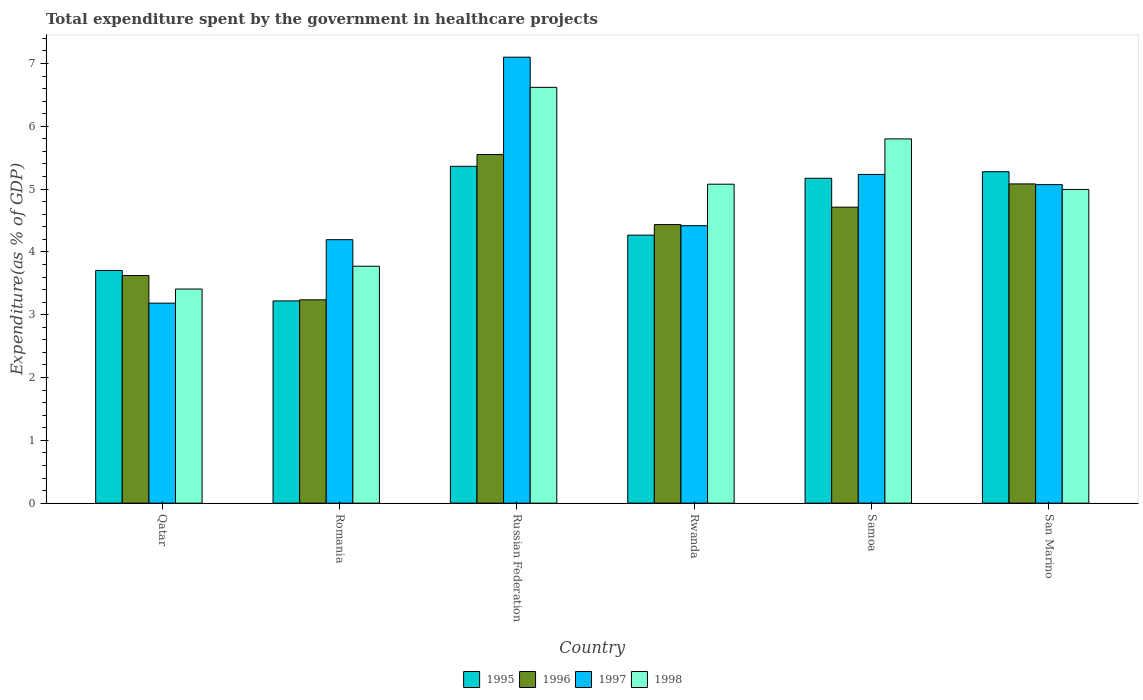Are the number of bars per tick equal to the number of legend labels?
Ensure brevity in your answer.  Yes. Are the number of bars on each tick of the X-axis equal?
Offer a terse response. Yes. How many bars are there on the 4th tick from the left?
Keep it short and to the point. 4. What is the label of the 6th group of bars from the left?
Your answer should be compact. San Marino. In how many cases, is the number of bars for a given country not equal to the number of legend labels?
Give a very brief answer. 0. What is the total expenditure spent by the government in healthcare projects in 1995 in Russian Federation?
Give a very brief answer. 5.36. Across all countries, what is the maximum total expenditure spent by the government in healthcare projects in 1997?
Make the answer very short. 7.1. Across all countries, what is the minimum total expenditure spent by the government in healthcare projects in 1996?
Your answer should be compact. 3.24. In which country was the total expenditure spent by the government in healthcare projects in 1997 maximum?
Offer a very short reply. Russian Federation. In which country was the total expenditure spent by the government in healthcare projects in 1995 minimum?
Keep it short and to the point. Romania. What is the total total expenditure spent by the government in healthcare projects in 1996 in the graph?
Provide a short and direct response. 26.64. What is the difference between the total expenditure spent by the government in healthcare projects in 1995 in Russian Federation and that in Rwanda?
Your response must be concise. 1.1. What is the difference between the total expenditure spent by the government in healthcare projects in 1996 in Rwanda and the total expenditure spent by the government in healthcare projects in 1997 in Romania?
Your answer should be very brief. 0.24. What is the average total expenditure spent by the government in healthcare projects in 1996 per country?
Provide a short and direct response. 4.44. What is the difference between the total expenditure spent by the government in healthcare projects of/in 1997 and total expenditure spent by the government in healthcare projects of/in 1998 in Rwanda?
Offer a terse response. -0.66. In how many countries, is the total expenditure spent by the government in healthcare projects in 1997 greater than 7.2 %?
Make the answer very short. 0. What is the ratio of the total expenditure spent by the government in healthcare projects in 1996 in Romania to that in Samoa?
Your answer should be compact. 0.69. Is the total expenditure spent by the government in healthcare projects in 1997 in Qatar less than that in San Marino?
Provide a succinct answer. Yes. Is the difference between the total expenditure spent by the government in healthcare projects in 1997 in Romania and Russian Federation greater than the difference between the total expenditure spent by the government in healthcare projects in 1998 in Romania and Russian Federation?
Your response must be concise. No. What is the difference between the highest and the second highest total expenditure spent by the government in healthcare projects in 1995?
Offer a very short reply. -0.1. What is the difference between the highest and the lowest total expenditure spent by the government in healthcare projects in 1996?
Give a very brief answer. 2.31. In how many countries, is the total expenditure spent by the government in healthcare projects in 1997 greater than the average total expenditure spent by the government in healthcare projects in 1997 taken over all countries?
Provide a short and direct response. 3. Is the sum of the total expenditure spent by the government in healthcare projects in 1995 in Russian Federation and Samoa greater than the maximum total expenditure spent by the government in healthcare projects in 1997 across all countries?
Offer a very short reply. Yes. Is it the case that in every country, the sum of the total expenditure spent by the government in healthcare projects in 1995 and total expenditure spent by the government in healthcare projects in 1998 is greater than the sum of total expenditure spent by the government in healthcare projects in 1997 and total expenditure spent by the government in healthcare projects in 1996?
Your answer should be very brief. No. How many bars are there?
Provide a succinct answer. 24. How many countries are there in the graph?
Your answer should be very brief. 6. What is the difference between two consecutive major ticks on the Y-axis?
Provide a succinct answer. 1. Does the graph contain any zero values?
Keep it short and to the point. No. Does the graph contain grids?
Make the answer very short. No. How many legend labels are there?
Your answer should be compact. 4. How are the legend labels stacked?
Your answer should be very brief. Horizontal. What is the title of the graph?
Offer a very short reply. Total expenditure spent by the government in healthcare projects. What is the label or title of the Y-axis?
Your response must be concise. Expenditure(as % of GDP). What is the Expenditure(as % of GDP) in 1995 in Qatar?
Offer a very short reply. 3.7. What is the Expenditure(as % of GDP) of 1996 in Qatar?
Offer a very short reply. 3.62. What is the Expenditure(as % of GDP) of 1997 in Qatar?
Provide a succinct answer. 3.18. What is the Expenditure(as % of GDP) in 1998 in Qatar?
Your response must be concise. 3.41. What is the Expenditure(as % of GDP) of 1995 in Romania?
Keep it short and to the point. 3.22. What is the Expenditure(as % of GDP) of 1996 in Romania?
Provide a succinct answer. 3.24. What is the Expenditure(as % of GDP) of 1997 in Romania?
Your response must be concise. 4.19. What is the Expenditure(as % of GDP) of 1998 in Romania?
Ensure brevity in your answer.  3.77. What is the Expenditure(as % of GDP) in 1995 in Russian Federation?
Your answer should be very brief. 5.36. What is the Expenditure(as % of GDP) in 1996 in Russian Federation?
Offer a terse response. 5.55. What is the Expenditure(as % of GDP) in 1997 in Russian Federation?
Your response must be concise. 7.1. What is the Expenditure(as % of GDP) of 1998 in Russian Federation?
Ensure brevity in your answer.  6.62. What is the Expenditure(as % of GDP) in 1995 in Rwanda?
Give a very brief answer. 4.27. What is the Expenditure(as % of GDP) of 1996 in Rwanda?
Your answer should be compact. 4.44. What is the Expenditure(as % of GDP) of 1997 in Rwanda?
Your answer should be compact. 4.42. What is the Expenditure(as % of GDP) in 1998 in Rwanda?
Provide a succinct answer. 5.08. What is the Expenditure(as % of GDP) of 1995 in Samoa?
Make the answer very short. 5.17. What is the Expenditure(as % of GDP) of 1996 in Samoa?
Your answer should be compact. 4.71. What is the Expenditure(as % of GDP) in 1997 in Samoa?
Your response must be concise. 5.23. What is the Expenditure(as % of GDP) of 1998 in Samoa?
Keep it short and to the point. 5.8. What is the Expenditure(as % of GDP) in 1995 in San Marino?
Offer a very short reply. 5.28. What is the Expenditure(as % of GDP) of 1996 in San Marino?
Offer a very short reply. 5.08. What is the Expenditure(as % of GDP) of 1997 in San Marino?
Keep it short and to the point. 5.07. What is the Expenditure(as % of GDP) of 1998 in San Marino?
Keep it short and to the point. 4.99. Across all countries, what is the maximum Expenditure(as % of GDP) of 1995?
Offer a very short reply. 5.36. Across all countries, what is the maximum Expenditure(as % of GDP) in 1996?
Your answer should be very brief. 5.55. Across all countries, what is the maximum Expenditure(as % of GDP) of 1997?
Provide a short and direct response. 7.1. Across all countries, what is the maximum Expenditure(as % of GDP) of 1998?
Make the answer very short. 6.62. Across all countries, what is the minimum Expenditure(as % of GDP) in 1995?
Keep it short and to the point. 3.22. Across all countries, what is the minimum Expenditure(as % of GDP) in 1996?
Your response must be concise. 3.24. Across all countries, what is the minimum Expenditure(as % of GDP) in 1997?
Offer a very short reply. 3.18. Across all countries, what is the minimum Expenditure(as % of GDP) of 1998?
Your answer should be very brief. 3.41. What is the total Expenditure(as % of GDP) in 1995 in the graph?
Provide a short and direct response. 27. What is the total Expenditure(as % of GDP) in 1996 in the graph?
Keep it short and to the point. 26.64. What is the total Expenditure(as % of GDP) of 1997 in the graph?
Give a very brief answer. 29.2. What is the total Expenditure(as % of GDP) in 1998 in the graph?
Keep it short and to the point. 29.67. What is the difference between the Expenditure(as % of GDP) of 1995 in Qatar and that in Romania?
Give a very brief answer. 0.48. What is the difference between the Expenditure(as % of GDP) of 1996 in Qatar and that in Romania?
Give a very brief answer. 0.39. What is the difference between the Expenditure(as % of GDP) in 1997 in Qatar and that in Romania?
Your answer should be compact. -1.01. What is the difference between the Expenditure(as % of GDP) of 1998 in Qatar and that in Romania?
Provide a succinct answer. -0.36. What is the difference between the Expenditure(as % of GDP) of 1995 in Qatar and that in Russian Federation?
Make the answer very short. -1.66. What is the difference between the Expenditure(as % of GDP) in 1996 in Qatar and that in Russian Federation?
Ensure brevity in your answer.  -1.93. What is the difference between the Expenditure(as % of GDP) in 1997 in Qatar and that in Russian Federation?
Provide a succinct answer. -3.92. What is the difference between the Expenditure(as % of GDP) of 1998 in Qatar and that in Russian Federation?
Ensure brevity in your answer.  -3.21. What is the difference between the Expenditure(as % of GDP) in 1995 in Qatar and that in Rwanda?
Give a very brief answer. -0.56. What is the difference between the Expenditure(as % of GDP) in 1996 in Qatar and that in Rwanda?
Your response must be concise. -0.81. What is the difference between the Expenditure(as % of GDP) in 1997 in Qatar and that in Rwanda?
Give a very brief answer. -1.23. What is the difference between the Expenditure(as % of GDP) in 1998 in Qatar and that in Rwanda?
Offer a terse response. -1.67. What is the difference between the Expenditure(as % of GDP) in 1995 in Qatar and that in Samoa?
Keep it short and to the point. -1.47. What is the difference between the Expenditure(as % of GDP) in 1996 in Qatar and that in Samoa?
Make the answer very short. -1.09. What is the difference between the Expenditure(as % of GDP) in 1997 in Qatar and that in Samoa?
Provide a short and direct response. -2.05. What is the difference between the Expenditure(as % of GDP) in 1998 in Qatar and that in Samoa?
Offer a very short reply. -2.39. What is the difference between the Expenditure(as % of GDP) of 1995 in Qatar and that in San Marino?
Provide a succinct answer. -1.57. What is the difference between the Expenditure(as % of GDP) of 1996 in Qatar and that in San Marino?
Ensure brevity in your answer.  -1.46. What is the difference between the Expenditure(as % of GDP) of 1997 in Qatar and that in San Marino?
Make the answer very short. -1.89. What is the difference between the Expenditure(as % of GDP) in 1998 in Qatar and that in San Marino?
Provide a succinct answer. -1.59. What is the difference between the Expenditure(as % of GDP) of 1995 in Romania and that in Russian Federation?
Ensure brevity in your answer.  -2.14. What is the difference between the Expenditure(as % of GDP) of 1996 in Romania and that in Russian Federation?
Make the answer very short. -2.31. What is the difference between the Expenditure(as % of GDP) in 1997 in Romania and that in Russian Federation?
Make the answer very short. -2.91. What is the difference between the Expenditure(as % of GDP) of 1998 in Romania and that in Russian Federation?
Your response must be concise. -2.85. What is the difference between the Expenditure(as % of GDP) in 1995 in Romania and that in Rwanda?
Make the answer very short. -1.05. What is the difference between the Expenditure(as % of GDP) of 1996 in Romania and that in Rwanda?
Provide a succinct answer. -1.2. What is the difference between the Expenditure(as % of GDP) of 1997 in Romania and that in Rwanda?
Provide a short and direct response. -0.22. What is the difference between the Expenditure(as % of GDP) of 1998 in Romania and that in Rwanda?
Provide a short and direct response. -1.31. What is the difference between the Expenditure(as % of GDP) of 1995 in Romania and that in Samoa?
Make the answer very short. -1.95. What is the difference between the Expenditure(as % of GDP) in 1996 in Romania and that in Samoa?
Offer a terse response. -1.48. What is the difference between the Expenditure(as % of GDP) in 1997 in Romania and that in Samoa?
Ensure brevity in your answer.  -1.04. What is the difference between the Expenditure(as % of GDP) of 1998 in Romania and that in Samoa?
Provide a short and direct response. -2.03. What is the difference between the Expenditure(as % of GDP) in 1995 in Romania and that in San Marino?
Your answer should be compact. -2.06. What is the difference between the Expenditure(as % of GDP) of 1996 in Romania and that in San Marino?
Keep it short and to the point. -1.85. What is the difference between the Expenditure(as % of GDP) in 1997 in Romania and that in San Marino?
Make the answer very short. -0.88. What is the difference between the Expenditure(as % of GDP) of 1998 in Romania and that in San Marino?
Your answer should be compact. -1.22. What is the difference between the Expenditure(as % of GDP) in 1995 in Russian Federation and that in Rwanda?
Offer a very short reply. 1.1. What is the difference between the Expenditure(as % of GDP) in 1996 in Russian Federation and that in Rwanda?
Offer a very short reply. 1.12. What is the difference between the Expenditure(as % of GDP) in 1997 in Russian Federation and that in Rwanda?
Provide a succinct answer. 2.68. What is the difference between the Expenditure(as % of GDP) of 1998 in Russian Federation and that in Rwanda?
Give a very brief answer. 1.54. What is the difference between the Expenditure(as % of GDP) in 1995 in Russian Federation and that in Samoa?
Make the answer very short. 0.19. What is the difference between the Expenditure(as % of GDP) of 1996 in Russian Federation and that in Samoa?
Your response must be concise. 0.84. What is the difference between the Expenditure(as % of GDP) of 1997 in Russian Federation and that in Samoa?
Provide a succinct answer. 1.87. What is the difference between the Expenditure(as % of GDP) in 1998 in Russian Federation and that in Samoa?
Your response must be concise. 0.82. What is the difference between the Expenditure(as % of GDP) of 1995 in Russian Federation and that in San Marino?
Give a very brief answer. 0.09. What is the difference between the Expenditure(as % of GDP) in 1996 in Russian Federation and that in San Marino?
Your answer should be very brief. 0.47. What is the difference between the Expenditure(as % of GDP) in 1997 in Russian Federation and that in San Marino?
Provide a succinct answer. 2.03. What is the difference between the Expenditure(as % of GDP) of 1998 in Russian Federation and that in San Marino?
Ensure brevity in your answer.  1.63. What is the difference between the Expenditure(as % of GDP) of 1995 in Rwanda and that in Samoa?
Give a very brief answer. -0.91. What is the difference between the Expenditure(as % of GDP) in 1996 in Rwanda and that in Samoa?
Offer a terse response. -0.28. What is the difference between the Expenditure(as % of GDP) in 1997 in Rwanda and that in Samoa?
Offer a very short reply. -0.82. What is the difference between the Expenditure(as % of GDP) of 1998 in Rwanda and that in Samoa?
Ensure brevity in your answer.  -0.72. What is the difference between the Expenditure(as % of GDP) of 1995 in Rwanda and that in San Marino?
Provide a succinct answer. -1.01. What is the difference between the Expenditure(as % of GDP) of 1996 in Rwanda and that in San Marino?
Offer a terse response. -0.65. What is the difference between the Expenditure(as % of GDP) in 1997 in Rwanda and that in San Marino?
Give a very brief answer. -0.65. What is the difference between the Expenditure(as % of GDP) of 1998 in Rwanda and that in San Marino?
Provide a succinct answer. 0.08. What is the difference between the Expenditure(as % of GDP) in 1995 in Samoa and that in San Marino?
Ensure brevity in your answer.  -0.1. What is the difference between the Expenditure(as % of GDP) of 1996 in Samoa and that in San Marino?
Keep it short and to the point. -0.37. What is the difference between the Expenditure(as % of GDP) of 1997 in Samoa and that in San Marino?
Ensure brevity in your answer.  0.16. What is the difference between the Expenditure(as % of GDP) of 1998 in Samoa and that in San Marino?
Provide a succinct answer. 0.8. What is the difference between the Expenditure(as % of GDP) of 1995 in Qatar and the Expenditure(as % of GDP) of 1996 in Romania?
Give a very brief answer. 0.47. What is the difference between the Expenditure(as % of GDP) in 1995 in Qatar and the Expenditure(as % of GDP) in 1997 in Romania?
Ensure brevity in your answer.  -0.49. What is the difference between the Expenditure(as % of GDP) of 1995 in Qatar and the Expenditure(as % of GDP) of 1998 in Romania?
Offer a terse response. -0.07. What is the difference between the Expenditure(as % of GDP) of 1996 in Qatar and the Expenditure(as % of GDP) of 1997 in Romania?
Your response must be concise. -0.57. What is the difference between the Expenditure(as % of GDP) in 1996 in Qatar and the Expenditure(as % of GDP) in 1998 in Romania?
Offer a very short reply. -0.15. What is the difference between the Expenditure(as % of GDP) of 1997 in Qatar and the Expenditure(as % of GDP) of 1998 in Romania?
Make the answer very short. -0.59. What is the difference between the Expenditure(as % of GDP) in 1995 in Qatar and the Expenditure(as % of GDP) in 1996 in Russian Federation?
Keep it short and to the point. -1.85. What is the difference between the Expenditure(as % of GDP) of 1995 in Qatar and the Expenditure(as % of GDP) of 1997 in Russian Federation?
Your response must be concise. -3.4. What is the difference between the Expenditure(as % of GDP) of 1995 in Qatar and the Expenditure(as % of GDP) of 1998 in Russian Federation?
Give a very brief answer. -2.92. What is the difference between the Expenditure(as % of GDP) in 1996 in Qatar and the Expenditure(as % of GDP) in 1997 in Russian Federation?
Offer a very short reply. -3.48. What is the difference between the Expenditure(as % of GDP) in 1996 in Qatar and the Expenditure(as % of GDP) in 1998 in Russian Federation?
Make the answer very short. -3. What is the difference between the Expenditure(as % of GDP) of 1997 in Qatar and the Expenditure(as % of GDP) of 1998 in Russian Federation?
Keep it short and to the point. -3.44. What is the difference between the Expenditure(as % of GDP) of 1995 in Qatar and the Expenditure(as % of GDP) of 1996 in Rwanda?
Provide a succinct answer. -0.73. What is the difference between the Expenditure(as % of GDP) of 1995 in Qatar and the Expenditure(as % of GDP) of 1997 in Rwanda?
Provide a succinct answer. -0.71. What is the difference between the Expenditure(as % of GDP) of 1995 in Qatar and the Expenditure(as % of GDP) of 1998 in Rwanda?
Give a very brief answer. -1.37. What is the difference between the Expenditure(as % of GDP) in 1996 in Qatar and the Expenditure(as % of GDP) in 1997 in Rwanda?
Keep it short and to the point. -0.79. What is the difference between the Expenditure(as % of GDP) in 1996 in Qatar and the Expenditure(as % of GDP) in 1998 in Rwanda?
Provide a short and direct response. -1.45. What is the difference between the Expenditure(as % of GDP) of 1997 in Qatar and the Expenditure(as % of GDP) of 1998 in Rwanda?
Offer a very short reply. -1.89. What is the difference between the Expenditure(as % of GDP) in 1995 in Qatar and the Expenditure(as % of GDP) in 1996 in Samoa?
Your answer should be compact. -1.01. What is the difference between the Expenditure(as % of GDP) in 1995 in Qatar and the Expenditure(as % of GDP) in 1997 in Samoa?
Your answer should be compact. -1.53. What is the difference between the Expenditure(as % of GDP) in 1995 in Qatar and the Expenditure(as % of GDP) in 1998 in Samoa?
Provide a succinct answer. -2.09. What is the difference between the Expenditure(as % of GDP) of 1996 in Qatar and the Expenditure(as % of GDP) of 1997 in Samoa?
Give a very brief answer. -1.61. What is the difference between the Expenditure(as % of GDP) in 1996 in Qatar and the Expenditure(as % of GDP) in 1998 in Samoa?
Provide a succinct answer. -2.18. What is the difference between the Expenditure(as % of GDP) of 1997 in Qatar and the Expenditure(as % of GDP) of 1998 in Samoa?
Your answer should be compact. -2.61. What is the difference between the Expenditure(as % of GDP) in 1995 in Qatar and the Expenditure(as % of GDP) in 1996 in San Marino?
Give a very brief answer. -1.38. What is the difference between the Expenditure(as % of GDP) of 1995 in Qatar and the Expenditure(as % of GDP) of 1997 in San Marino?
Your answer should be very brief. -1.37. What is the difference between the Expenditure(as % of GDP) in 1995 in Qatar and the Expenditure(as % of GDP) in 1998 in San Marino?
Keep it short and to the point. -1.29. What is the difference between the Expenditure(as % of GDP) of 1996 in Qatar and the Expenditure(as % of GDP) of 1997 in San Marino?
Give a very brief answer. -1.45. What is the difference between the Expenditure(as % of GDP) in 1996 in Qatar and the Expenditure(as % of GDP) in 1998 in San Marino?
Make the answer very short. -1.37. What is the difference between the Expenditure(as % of GDP) in 1997 in Qatar and the Expenditure(as % of GDP) in 1998 in San Marino?
Provide a short and direct response. -1.81. What is the difference between the Expenditure(as % of GDP) of 1995 in Romania and the Expenditure(as % of GDP) of 1996 in Russian Federation?
Your answer should be compact. -2.33. What is the difference between the Expenditure(as % of GDP) of 1995 in Romania and the Expenditure(as % of GDP) of 1997 in Russian Federation?
Provide a short and direct response. -3.88. What is the difference between the Expenditure(as % of GDP) of 1995 in Romania and the Expenditure(as % of GDP) of 1998 in Russian Federation?
Provide a short and direct response. -3.4. What is the difference between the Expenditure(as % of GDP) in 1996 in Romania and the Expenditure(as % of GDP) in 1997 in Russian Federation?
Make the answer very short. -3.86. What is the difference between the Expenditure(as % of GDP) of 1996 in Romania and the Expenditure(as % of GDP) of 1998 in Russian Federation?
Your answer should be compact. -3.38. What is the difference between the Expenditure(as % of GDP) of 1997 in Romania and the Expenditure(as % of GDP) of 1998 in Russian Federation?
Give a very brief answer. -2.43. What is the difference between the Expenditure(as % of GDP) of 1995 in Romania and the Expenditure(as % of GDP) of 1996 in Rwanda?
Provide a short and direct response. -1.22. What is the difference between the Expenditure(as % of GDP) in 1995 in Romania and the Expenditure(as % of GDP) in 1997 in Rwanda?
Provide a succinct answer. -1.2. What is the difference between the Expenditure(as % of GDP) in 1995 in Romania and the Expenditure(as % of GDP) in 1998 in Rwanda?
Your response must be concise. -1.86. What is the difference between the Expenditure(as % of GDP) in 1996 in Romania and the Expenditure(as % of GDP) in 1997 in Rwanda?
Provide a short and direct response. -1.18. What is the difference between the Expenditure(as % of GDP) of 1996 in Romania and the Expenditure(as % of GDP) of 1998 in Rwanda?
Make the answer very short. -1.84. What is the difference between the Expenditure(as % of GDP) in 1997 in Romania and the Expenditure(as % of GDP) in 1998 in Rwanda?
Your response must be concise. -0.88. What is the difference between the Expenditure(as % of GDP) in 1995 in Romania and the Expenditure(as % of GDP) in 1996 in Samoa?
Keep it short and to the point. -1.49. What is the difference between the Expenditure(as % of GDP) of 1995 in Romania and the Expenditure(as % of GDP) of 1997 in Samoa?
Provide a short and direct response. -2.01. What is the difference between the Expenditure(as % of GDP) of 1995 in Romania and the Expenditure(as % of GDP) of 1998 in Samoa?
Your answer should be compact. -2.58. What is the difference between the Expenditure(as % of GDP) of 1996 in Romania and the Expenditure(as % of GDP) of 1997 in Samoa?
Give a very brief answer. -2. What is the difference between the Expenditure(as % of GDP) of 1996 in Romania and the Expenditure(as % of GDP) of 1998 in Samoa?
Your answer should be very brief. -2.56. What is the difference between the Expenditure(as % of GDP) in 1997 in Romania and the Expenditure(as % of GDP) in 1998 in Samoa?
Offer a terse response. -1.6. What is the difference between the Expenditure(as % of GDP) of 1995 in Romania and the Expenditure(as % of GDP) of 1996 in San Marino?
Offer a terse response. -1.86. What is the difference between the Expenditure(as % of GDP) of 1995 in Romania and the Expenditure(as % of GDP) of 1997 in San Marino?
Make the answer very short. -1.85. What is the difference between the Expenditure(as % of GDP) of 1995 in Romania and the Expenditure(as % of GDP) of 1998 in San Marino?
Offer a terse response. -1.77. What is the difference between the Expenditure(as % of GDP) of 1996 in Romania and the Expenditure(as % of GDP) of 1997 in San Marino?
Offer a very short reply. -1.83. What is the difference between the Expenditure(as % of GDP) of 1996 in Romania and the Expenditure(as % of GDP) of 1998 in San Marino?
Your response must be concise. -1.76. What is the difference between the Expenditure(as % of GDP) of 1997 in Romania and the Expenditure(as % of GDP) of 1998 in San Marino?
Ensure brevity in your answer.  -0.8. What is the difference between the Expenditure(as % of GDP) of 1995 in Russian Federation and the Expenditure(as % of GDP) of 1996 in Rwanda?
Make the answer very short. 0.93. What is the difference between the Expenditure(as % of GDP) of 1995 in Russian Federation and the Expenditure(as % of GDP) of 1997 in Rwanda?
Your answer should be very brief. 0.95. What is the difference between the Expenditure(as % of GDP) in 1995 in Russian Federation and the Expenditure(as % of GDP) in 1998 in Rwanda?
Your answer should be compact. 0.28. What is the difference between the Expenditure(as % of GDP) of 1996 in Russian Federation and the Expenditure(as % of GDP) of 1997 in Rwanda?
Your answer should be very brief. 1.13. What is the difference between the Expenditure(as % of GDP) in 1996 in Russian Federation and the Expenditure(as % of GDP) in 1998 in Rwanda?
Make the answer very short. 0.47. What is the difference between the Expenditure(as % of GDP) of 1997 in Russian Federation and the Expenditure(as % of GDP) of 1998 in Rwanda?
Provide a short and direct response. 2.02. What is the difference between the Expenditure(as % of GDP) of 1995 in Russian Federation and the Expenditure(as % of GDP) of 1996 in Samoa?
Provide a succinct answer. 0.65. What is the difference between the Expenditure(as % of GDP) of 1995 in Russian Federation and the Expenditure(as % of GDP) of 1997 in Samoa?
Offer a terse response. 0.13. What is the difference between the Expenditure(as % of GDP) of 1995 in Russian Federation and the Expenditure(as % of GDP) of 1998 in Samoa?
Keep it short and to the point. -0.44. What is the difference between the Expenditure(as % of GDP) in 1996 in Russian Federation and the Expenditure(as % of GDP) in 1997 in Samoa?
Provide a short and direct response. 0.32. What is the difference between the Expenditure(as % of GDP) of 1996 in Russian Federation and the Expenditure(as % of GDP) of 1998 in Samoa?
Offer a terse response. -0.25. What is the difference between the Expenditure(as % of GDP) in 1997 in Russian Federation and the Expenditure(as % of GDP) in 1998 in Samoa?
Make the answer very short. 1.3. What is the difference between the Expenditure(as % of GDP) of 1995 in Russian Federation and the Expenditure(as % of GDP) of 1996 in San Marino?
Your answer should be very brief. 0.28. What is the difference between the Expenditure(as % of GDP) in 1995 in Russian Federation and the Expenditure(as % of GDP) in 1997 in San Marino?
Provide a short and direct response. 0.29. What is the difference between the Expenditure(as % of GDP) in 1995 in Russian Federation and the Expenditure(as % of GDP) in 1998 in San Marino?
Make the answer very short. 0.37. What is the difference between the Expenditure(as % of GDP) in 1996 in Russian Federation and the Expenditure(as % of GDP) in 1997 in San Marino?
Offer a very short reply. 0.48. What is the difference between the Expenditure(as % of GDP) in 1996 in Russian Federation and the Expenditure(as % of GDP) in 1998 in San Marino?
Offer a terse response. 0.56. What is the difference between the Expenditure(as % of GDP) in 1997 in Russian Federation and the Expenditure(as % of GDP) in 1998 in San Marino?
Your response must be concise. 2.11. What is the difference between the Expenditure(as % of GDP) of 1995 in Rwanda and the Expenditure(as % of GDP) of 1996 in Samoa?
Your response must be concise. -0.44. What is the difference between the Expenditure(as % of GDP) of 1995 in Rwanda and the Expenditure(as % of GDP) of 1997 in Samoa?
Give a very brief answer. -0.97. What is the difference between the Expenditure(as % of GDP) in 1995 in Rwanda and the Expenditure(as % of GDP) in 1998 in Samoa?
Keep it short and to the point. -1.53. What is the difference between the Expenditure(as % of GDP) of 1996 in Rwanda and the Expenditure(as % of GDP) of 1997 in Samoa?
Give a very brief answer. -0.8. What is the difference between the Expenditure(as % of GDP) in 1996 in Rwanda and the Expenditure(as % of GDP) in 1998 in Samoa?
Your answer should be compact. -1.36. What is the difference between the Expenditure(as % of GDP) of 1997 in Rwanda and the Expenditure(as % of GDP) of 1998 in Samoa?
Ensure brevity in your answer.  -1.38. What is the difference between the Expenditure(as % of GDP) in 1995 in Rwanda and the Expenditure(as % of GDP) in 1996 in San Marino?
Make the answer very short. -0.82. What is the difference between the Expenditure(as % of GDP) in 1995 in Rwanda and the Expenditure(as % of GDP) in 1997 in San Marino?
Offer a terse response. -0.8. What is the difference between the Expenditure(as % of GDP) of 1995 in Rwanda and the Expenditure(as % of GDP) of 1998 in San Marino?
Your answer should be very brief. -0.73. What is the difference between the Expenditure(as % of GDP) of 1996 in Rwanda and the Expenditure(as % of GDP) of 1997 in San Marino?
Your answer should be very brief. -0.64. What is the difference between the Expenditure(as % of GDP) of 1996 in Rwanda and the Expenditure(as % of GDP) of 1998 in San Marino?
Keep it short and to the point. -0.56. What is the difference between the Expenditure(as % of GDP) of 1997 in Rwanda and the Expenditure(as % of GDP) of 1998 in San Marino?
Offer a very short reply. -0.58. What is the difference between the Expenditure(as % of GDP) in 1995 in Samoa and the Expenditure(as % of GDP) in 1996 in San Marino?
Give a very brief answer. 0.09. What is the difference between the Expenditure(as % of GDP) in 1995 in Samoa and the Expenditure(as % of GDP) in 1997 in San Marino?
Ensure brevity in your answer.  0.1. What is the difference between the Expenditure(as % of GDP) in 1995 in Samoa and the Expenditure(as % of GDP) in 1998 in San Marino?
Ensure brevity in your answer.  0.18. What is the difference between the Expenditure(as % of GDP) in 1996 in Samoa and the Expenditure(as % of GDP) in 1997 in San Marino?
Provide a short and direct response. -0.36. What is the difference between the Expenditure(as % of GDP) in 1996 in Samoa and the Expenditure(as % of GDP) in 1998 in San Marino?
Your answer should be compact. -0.28. What is the difference between the Expenditure(as % of GDP) in 1997 in Samoa and the Expenditure(as % of GDP) in 1998 in San Marino?
Your response must be concise. 0.24. What is the average Expenditure(as % of GDP) in 1995 per country?
Make the answer very short. 4.5. What is the average Expenditure(as % of GDP) in 1996 per country?
Give a very brief answer. 4.44. What is the average Expenditure(as % of GDP) of 1997 per country?
Your answer should be very brief. 4.87. What is the average Expenditure(as % of GDP) in 1998 per country?
Ensure brevity in your answer.  4.95. What is the difference between the Expenditure(as % of GDP) in 1995 and Expenditure(as % of GDP) in 1996 in Qatar?
Offer a terse response. 0.08. What is the difference between the Expenditure(as % of GDP) in 1995 and Expenditure(as % of GDP) in 1997 in Qatar?
Your response must be concise. 0.52. What is the difference between the Expenditure(as % of GDP) of 1995 and Expenditure(as % of GDP) of 1998 in Qatar?
Offer a terse response. 0.3. What is the difference between the Expenditure(as % of GDP) of 1996 and Expenditure(as % of GDP) of 1997 in Qatar?
Make the answer very short. 0.44. What is the difference between the Expenditure(as % of GDP) of 1996 and Expenditure(as % of GDP) of 1998 in Qatar?
Your response must be concise. 0.21. What is the difference between the Expenditure(as % of GDP) in 1997 and Expenditure(as % of GDP) in 1998 in Qatar?
Provide a short and direct response. -0.22. What is the difference between the Expenditure(as % of GDP) in 1995 and Expenditure(as % of GDP) in 1996 in Romania?
Offer a terse response. -0.02. What is the difference between the Expenditure(as % of GDP) of 1995 and Expenditure(as % of GDP) of 1997 in Romania?
Make the answer very short. -0.97. What is the difference between the Expenditure(as % of GDP) in 1995 and Expenditure(as % of GDP) in 1998 in Romania?
Give a very brief answer. -0.55. What is the difference between the Expenditure(as % of GDP) in 1996 and Expenditure(as % of GDP) in 1997 in Romania?
Your response must be concise. -0.96. What is the difference between the Expenditure(as % of GDP) of 1996 and Expenditure(as % of GDP) of 1998 in Romania?
Make the answer very short. -0.53. What is the difference between the Expenditure(as % of GDP) of 1997 and Expenditure(as % of GDP) of 1998 in Romania?
Provide a succinct answer. 0.42. What is the difference between the Expenditure(as % of GDP) of 1995 and Expenditure(as % of GDP) of 1996 in Russian Federation?
Make the answer very short. -0.19. What is the difference between the Expenditure(as % of GDP) in 1995 and Expenditure(as % of GDP) in 1997 in Russian Federation?
Your answer should be very brief. -1.74. What is the difference between the Expenditure(as % of GDP) in 1995 and Expenditure(as % of GDP) in 1998 in Russian Federation?
Offer a terse response. -1.26. What is the difference between the Expenditure(as % of GDP) in 1996 and Expenditure(as % of GDP) in 1997 in Russian Federation?
Your answer should be compact. -1.55. What is the difference between the Expenditure(as % of GDP) of 1996 and Expenditure(as % of GDP) of 1998 in Russian Federation?
Your response must be concise. -1.07. What is the difference between the Expenditure(as % of GDP) in 1997 and Expenditure(as % of GDP) in 1998 in Russian Federation?
Make the answer very short. 0.48. What is the difference between the Expenditure(as % of GDP) in 1995 and Expenditure(as % of GDP) in 1996 in Rwanda?
Make the answer very short. -0.17. What is the difference between the Expenditure(as % of GDP) in 1995 and Expenditure(as % of GDP) in 1997 in Rwanda?
Offer a terse response. -0.15. What is the difference between the Expenditure(as % of GDP) in 1995 and Expenditure(as % of GDP) in 1998 in Rwanda?
Give a very brief answer. -0.81. What is the difference between the Expenditure(as % of GDP) of 1996 and Expenditure(as % of GDP) of 1997 in Rwanda?
Your answer should be very brief. 0.02. What is the difference between the Expenditure(as % of GDP) in 1996 and Expenditure(as % of GDP) in 1998 in Rwanda?
Ensure brevity in your answer.  -0.64. What is the difference between the Expenditure(as % of GDP) of 1997 and Expenditure(as % of GDP) of 1998 in Rwanda?
Ensure brevity in your answer.  -0.66. What is the difference between the Expenditure(as % of GDP) of 1995 and Expenditure(as % of GDP) of 1996 in Samoa?
Keep it short and to the point. 0.46. What is the difference between the Expenditure(as % of GDP) in 1995 and Expenditure(as % of GDP) in 1997 in Samoa?
Make the answer very short. -0.06. What is the difference between the Expenditure(as % of GDP) of 1995 and Expenditure(as % of GDP) of 1998 in Samoa?
Your answer should be very brief. -0.63. What is the difference between the Expenditure(as % of GDP) in 1996 and Expenditure(as % of GDP) in 1997 in Samoa?
Ensure brevity in your answer.  -0.52. What is the difference between the Expenditure(as % of GDP) in 1996 and Expenditure(as % of GDP) in 1998 in Samoa?
Make the answer very short. -1.09. What is the difference between the Expenditure(as % of GDP) of 1997 and Expenditure(as % of GDP) of 1998 in Samoa?
Your response must be concise. -0.57. What is the difference between the Expenditure(as % of GDP) of 1995 and Expenditure(as % of GDP) of 1996 in San Marino?
Make the answer very short. 0.19. What is the difference between the Expenditure(as % of GDP) in 1995 and Expenditure(as % of GDP) in 1997 in San Marino?
Keep it short and to the point. 0.21. What is the difference between the Expenditure(as % of GDP) in 1995 and Expenditure(as % of GDP) in 1998 in San Marino?
Give a very brief answer. 0.28. What is the difference between the Expenditure(as % of GDP) in 1996 and Expenditure(as % of GDP) in 1997 in San Marino?
Keep it short and to the point. 0.01. What is the difference between the Expenditure(as % of GDP) in 1996 and Expenditure(as % of GDP) in 1998 in San Marino?
Make the answer very short. 0.09. What is the difference between the Expenditure(as % of GDP) in 1997 and Expenditure(as % of GDP) in 1998 in San Marino?
Offer a very short reply. 0.08. What is the ratio of the Expenditure(as % of GDP) in 1995 in Qatar to that in Romania?
Your response must be concise. 1.15. What is the ratio of the Expenditure(as % of GDP) of 1996 in Qatar to that in Romania?
Provide a short and direct response. 1.12. What is the ratio of the Expenditure(as % of GDP) of 1997 in Qatar to that in Romania?
Provide a succinct answer. 0.76. What is the ratio of the Expenditure(as % of GDP) of 1998 in Qatar to that in Romania?
Keep it short and to the point. 0.9. What is the ratio of the Expenditure(as % of GDP) of 1995 in Qatar to that in Russian Federation?
Your response must be concise. 0.69. What is the ratio of the Expenditure(as % of GDP) of 1996 in Qatar to that in Russian Federation?
Your answer should be compact. 0.65. What is the ratio of the Expenditure(as % of GDP) of 1997 in Qatar to that in Russian Federation?
Your answer should be very brief. 0.45. What is the ratio of the Expenditure(as % of GDP) in 1998 in Qatar to that in Russian Federation?
Make the answer very short. 0.52. What is the ratio of the Expenditure(as % of GDP) of 1995 in Qatar to that in Rwanda?
Make the answer very short. 0.87. What is the ratio of the Expenditure(as % of GDP) in 1996 in Qatar to that in Rwanda?
Keep it short and to the point. 0.82. What is the ratio of the Expenditure(as % of GDP) of 1997 in Qatar to that in Rwanda?
Keep it short and to the point. 0.72. What is the ratio of the Expenditure(as % of GDP) of 1998 in Qatar to that in Rwanda?
Your answer should be very brief. 0.67. What is the ratio of the Expenditure(as % of GDP) of 1995 in Qatar to that in Samoa?
Ensure brevity in your answer.  0.72. What is the ratio of the Expenditure(as % of GDP) in 1996 in Qatar to that in Samoa?
Your answer should be very brief. 0.77. What is the ratio of the Expenditure(as % of GDP) of 1997 in Qatar to that in Samoa?
Ensure brevity in your answer.  0.61. What is the ratio of the Expenditure(as % of GDP) in 1998 in Qatar to that in Samoa?
Keep it short and to the point. 0.59. What is the ratio of the Expenditure(as % of GDP) in 1995 in Qatar to that in San Marino?
Make the answer very short. 0.7. What is the ratio of the Expenditure(as % of GDP) in 1996 in Qatar to that in San Marino?
Offer a terse response. 0.71. What is the ratio of the Expenditure(as % of GDP) in 1997 in Qatar to that in San Marino?
Keep it short and to the point. 0.63. What is the ratio of the Expenditure(as % of GDP) in 1998 in Qatar to that in San Marino?
Provide a short and direct response. 0.68. What is the ratio of the Expenditure(as % of GDP) of 1995 in Romania to that in Russian Federation?
Offer a terse response. 0.6. What is the ratio of the Expenditure(as % of GDP) of 1996 in Romania to that in Russian Federation?
Ensure brevity in your answer.  0.58. What is the ratio of the Expenditure(as % of GDP) of 1997 in Romania to that in Russian Federation?
Provide a succinct answer. 0.59. What is the ratio of the Expenditure(as % of GDP) of 1998 in Romania to that in Russian Federation?
Your answer should be compact. 0.57. What is the ratio of the Expenditure(as % of GDP) in 1995 in Romania to that in Rwanda?
Your response must be concise. 0.75. What is the ratio of the Expenditure(as % of GDP) in 1996 in Romania to that in Rwanda?
Keep it short and to the point. 0.73. What is the ratio of the Expenditure(as % of GDP) of 1997 in Romania to that in Rwanda?
Provide a succinct answer. 0.95. What is the ratio of the Expenditure(as % of GDP) of 1998 in Romania to that in Rwanda?
Make the answer very short. 0.74. What is the ratio of the Expenditure(as % of GDP) of 1995 in Romania to that in Samoa?
Keep it short and to the point. 0.62. What is the ratio of the Expenditure(as % of GDP) in 1996 in Romania to that in Samoa?
Provide a succinct answer. 0.69. What is the ratio of the Expenditure(as % of GDP) in 1997 in Romania to that in Samoa?
Offer a terse response. 0.8. What is the ratio of the Expenditure(as % of GDP) of 1998 in Romania to that in Samoa?
Offer a very short reply. 0.65. What is the ratio of the Expenditure(as % of GDP) in 1995 in Romania to that in San Marino?
Offer a terse response. 0.61. What is the ratio of the Expenditure(as % of GDP) in 1996 in Romania to that in San Marino?
Your answer should be compact. 0.64. What is the ratio of the Expenditure(as % of GDP) of 1997 in Romania to that in San Marino?
Offer a very short reply. 0.83. What is the ratio of the Expenditure(as % of GDP) of 1998 in Romania to that in San Marino?
Give a very brief answer. 0.76. What is the ratio of the Expenditure(as % of GDP) of 1995 in Russian Federation to that in Rwanda?
Your answer should be very brief. 1.26. What is the ratio of the Expenditure(as % of GDP) of 1996 in Russian Federation to that in Rwanda?
Your answer should be very brief. 1.25. What is the ratio of the Expenditure(as % of GDP) in 1997 in Russian Federation to that in Rwanda?
Your answer should be very brief. 1.61. What is the ratio of the Expenditure(as % of GDP) of 1998 in Russian Federation to that in Rwanda?
Give a very brief answer. 1.3. What is the ratio of the Expenditure(as % of GDP) in 1995 in Russian Federation to that in Samoa?
Offer a terse response. 1.04. What is the ratio of the Expenditure(as % of GDP) of 1996 in Russian Federation to that in Samoa?
Your answer should be very brief. 1.18. What is the ratio of the Expenditure(as % of GDP) in 1997 in Russian Federation to that in Samoa?
Offer a very short reply. 1.36. What is the ratio of the Expenditure(as % of GDP) in 1998 in Russian Federation to that in Samoa?
Keep it short and to the point. 1.14. What is the ratio of the Expenditure(as % of GDP) of 1995 in Russian Federation to that in San Marino?
Ensure brevity in your answer.  1.02. What is the ratio of the Expenditure(as % of GDP) in 1996 in Russian Federation to that in San Marino?
Ensure brevity in your answer.  1.09. What is the ratio of the Expenditure(as % of GDP) of 1997 in Russian Federation to that in San Marino?
Offer a very short reply. 1.4. What is the ratio of the Expenditure(as % of GDP) of 1998 in Russian Federation to that in San Marino?
Provide a short and direct response. 1.33. What is the ratio of the Expenditure(as % of GDP) in 1995 in Rwanda to that in Samoa?
Your response must be concise. 0.82. What is the ratio of the Expenditure(as % of GDP) in 1996 in Rwanda to that in Samoa?
Give a very brief answer. 0.94. What is the ratio of the Expenditure(as % of GDP) of 1997 in Rwanda to that in Samoa?
Provide a short and direct response. 0.84. What is the ratio of the Expenditure(as % of GDP) of 1998 in Rwanda to that in Samoa?
Ensure brevity in your answer.  0.88. What is the ratio of the Expenditure(as % of GDP) of 1995 in Rwanda to that in San Marino?
Give a very brief answer. 0.81. What is the ratio of the Expenditure(as % of GDP) in 1996 in Rwanda to that in San Marino?
Provide a short and direct response. 0.87. What is the ratio of the Expenditure(as % of GDP) of 1997 in Rwanda to that in San Marino?
Offer a very short reply. 0.87. What is the ratio of the Expenditure(as % of GDP) in 1998 in Rwanda to that in San Marino?
Keep it short and to the point. 1.02. What is the ratio of the Expenditure(as % of GDP) in 1995 in Samoa to that in San Marino?
Your answer should be very brief. 0.98. What is the ratio of the Expenditure(as % of GDP) of 1996 in Samoa to that in San Marino?
Offer a very short reply. 0.93. What is the ratio of the Expenditure(as % of GDP) in 1997 in Samoa to that in San Marino?
Offer a very short reply. 1.03. What is the ratio of the Expenditure(as % of GDP) in 1998 in Samoa to that in San Marino?
Give a very brief answer. 1.16. What is the difference between the highest and the second highest Expenditure(as % of GDP) of 1995?
Your answer should be very brief. 0.09. What is the difference between the highest and the second highest Expenditure(as % of GDP) in 1996?
Provide a short and direct response. 0.47. What is the difference between the highest and the second highest Expenditure(as % of GDP) in 1997?
Keep it short and to the point. 1.87. What is the difference between the highest and the second highest Expenditure(as % of GDP) in 1998?
Give a very brief answer. 0.82. What is the difference between the highest and the lowest Expenditure(as % of GDP) in 1995?
Your answer should be very brief. 2.14. What is the difference between the highest and the lowest Expenditure(as % of GDP) in 1996?
Ensure brevity in your answer.  2.31. What is the difference between the highest and the lowest Expenditure(as % of GDP) of 1997?
Give a very brief answer. 3.92. What is the difference between the highest and the lowest Expenditure(as % of GDP) of 1998?
Keep it short and to the point. 3.21. 